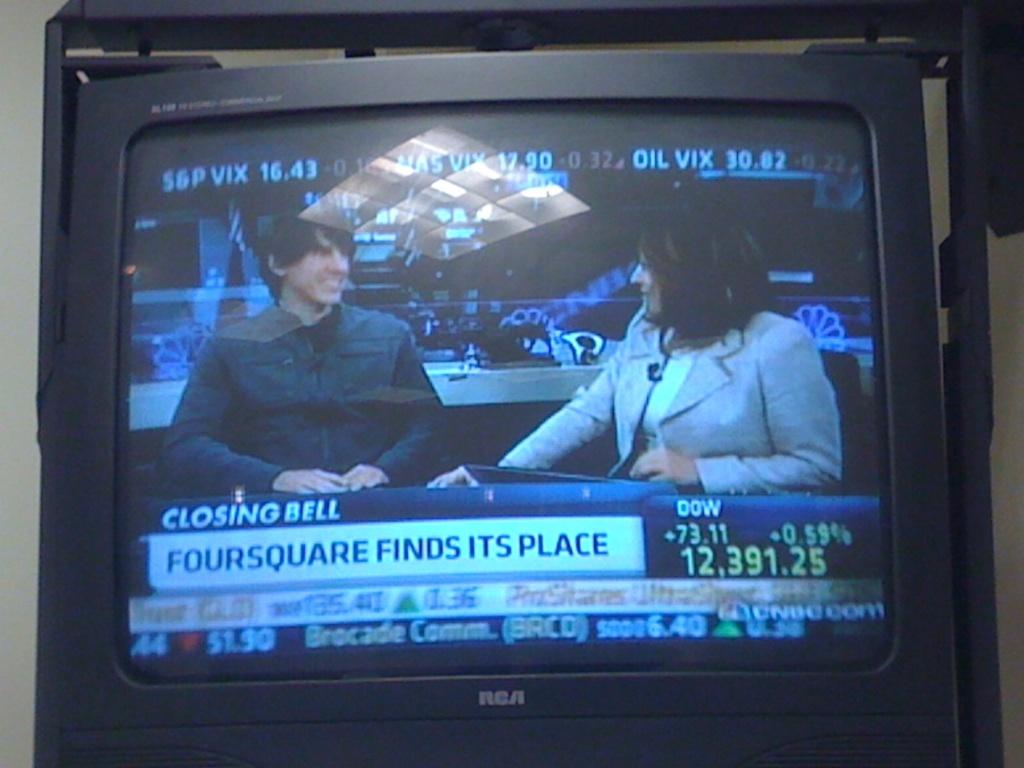Who finds it's place?
Provide a succinct answer. Foursquare. What channel is this?
Keep it short and to the point. Cnbc. 